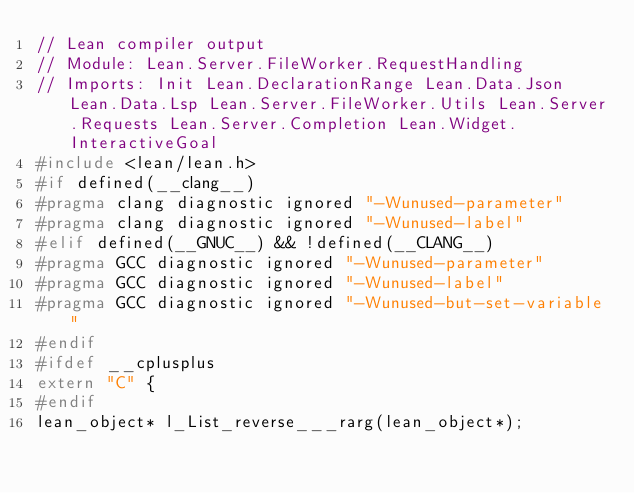Convert code to text. <code><loc_0><loc_0><loc_500><loc_500><_C_>// Lean compiler output
// Module: Lean.Server.FileWorker.RequestHandling
// Imports: Init Lean.DeclarationRange Lean.Data.Json Lean.Data.Lsp Lean.Server.FileWorker.Utils Lean.Server.Requests Lean.Server.Completion Lean.Widget.InteractiveGoal
#include <lean/lean.h>
#if defined(__clang__)
#pragma clang diagnostic ignored "-Wunused-parameter"
#pragma clang diagnostic ignored "-Wunused-label"
#elif defined(__GNUC__) && !defined(__CLANG__)
#pragma GCC diagnostic ignored "-Wunused-parameter"
#pragma GCC diagnostic ignored "-Wunused-label"
#pragma GCC diagnostic ignored "-Wunused-but-set-variable"
#endif
#ifdef __cplusplus
extern "C" {
#endif
lean_object* l_List_reverse___rarg(lean_object*);</code> 